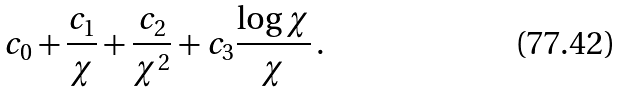<formula> <loc_0><loc_0><loc_500><loc_500>c _ { 0 } + \frac { c _ { 1 } } { \chi } + \frac { c _ { 2 } } { \chi ^ { 2 } } + c _ { 3 } \frac { \log \chi } { \chi } \, .</formula> 